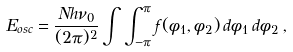<formula> <loc_0><loc_0><loc_500><loc_500>E _ { o s c } = \frac { N h \nu _ { 0 } } { ( 2 \pi ) ^ { 2 } } \int \int _ { - \pi } ^ { \pi } f ( \phi _ { 1 } , \phi _ { 2 } ) \, d \phi _ { 1 } \, d \phi _ { 2 } \, ,</formula> 